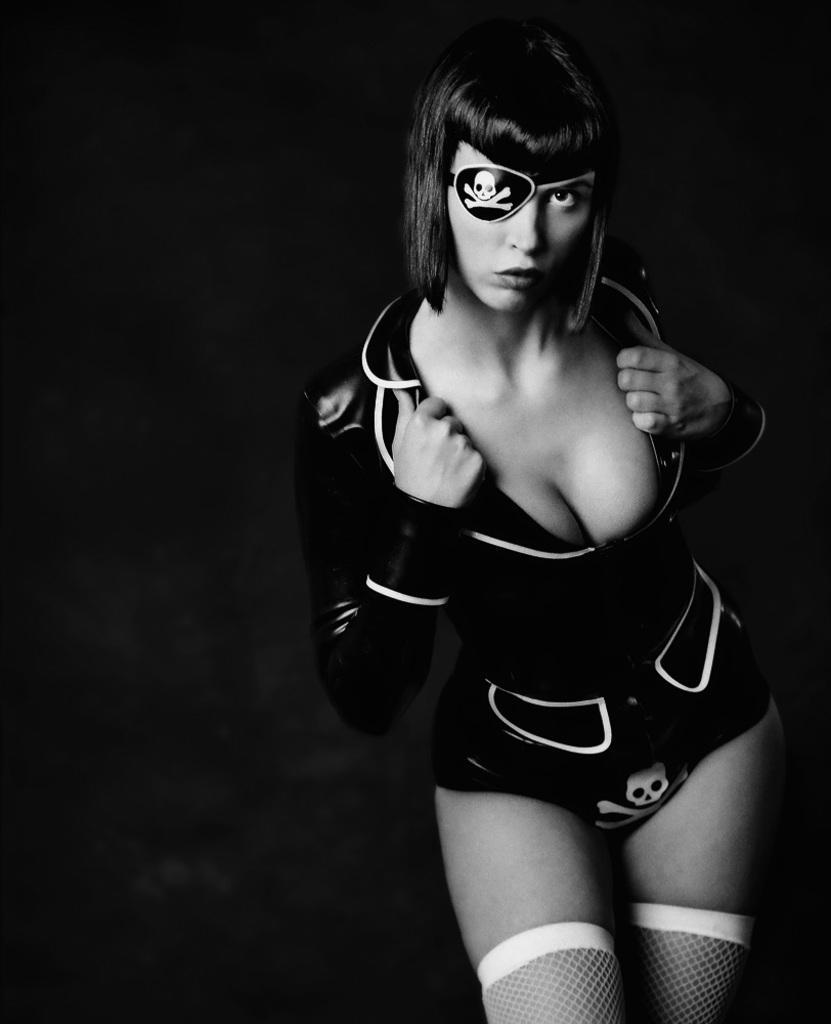Could you give a brief overview of what you see in this image? In the picture we can see a black and white photograph of a woman standing and showing her dress and behind her we can see a black surface. 